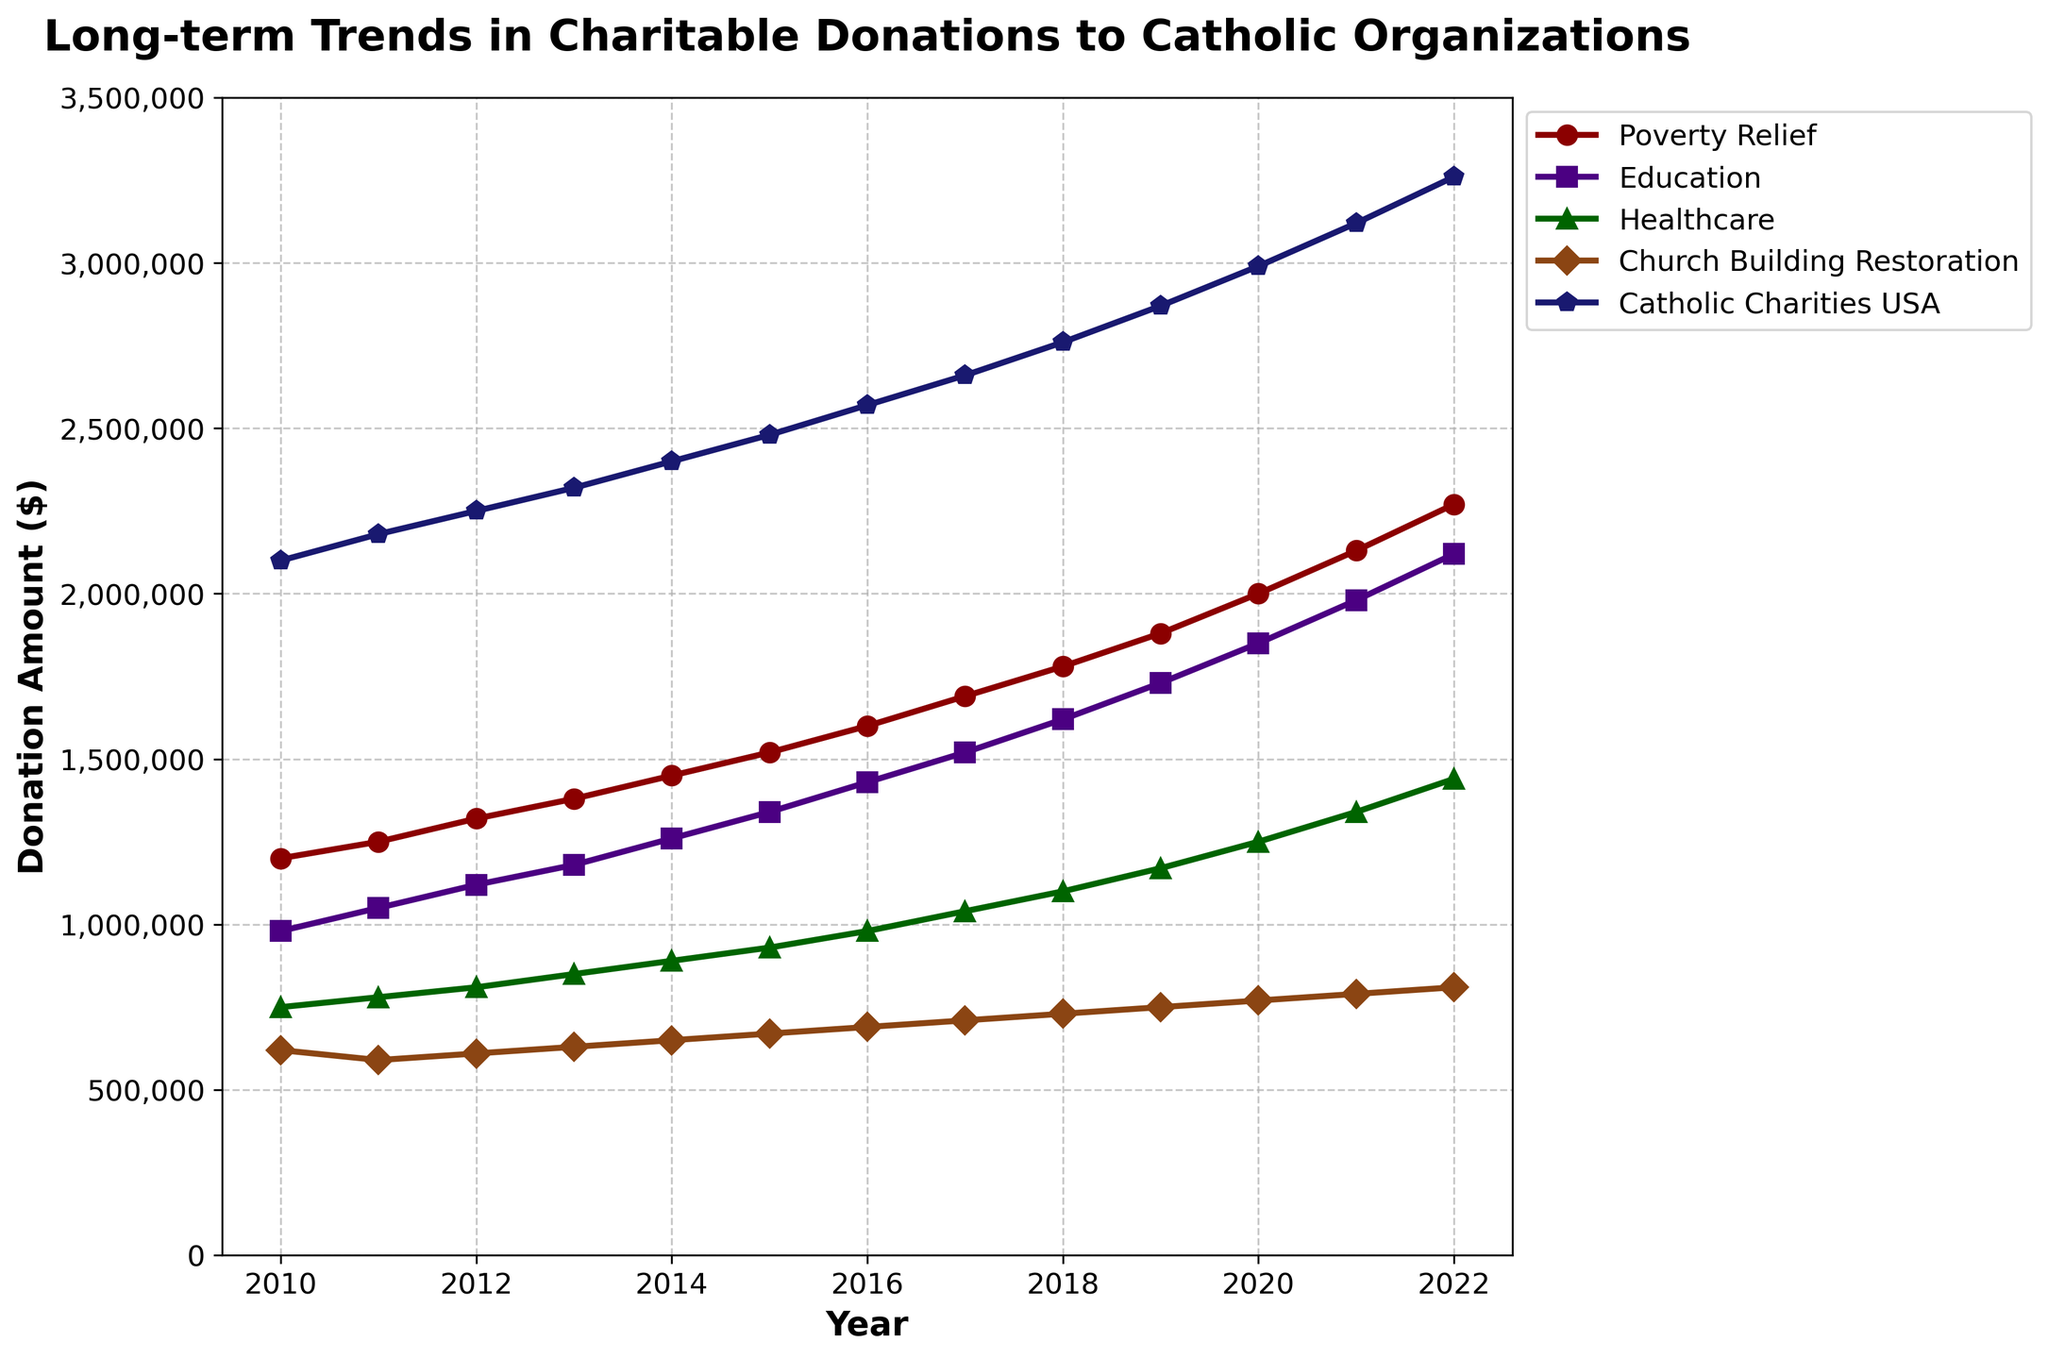What is the total donation amount for Education in 2022? The figure shows the donation amount for Education in 2022 to be $2,120,000. Simply refer to the value marked at 2022 for Education.
Answer: $2,120,000 Which year had the highest donation amount for Poverty Relief? By observing the trend for Poverty Relief, the donation amount has been increasing over the years. The peak value occurs in 2022.
Answer: 2022 In which year did Healthcare donations first surpass $900,000? Track the line for Healthcare and identify the year when it crossed the $900,000 mark. The first year it surpassed this amount is 2015.
Answer: 2015 By how much did the donations to Catholic Charities USA increase from 2010 to 2022? The donation amount in 2010 is $2,100,000 and in 2022 is $3,260,000. The difference is $3,260,000 - $2,100,000 = $1,160,000.
Answer: $1,160,000 Compare the donation amounts between Education and Church Building Restoration in 2017. Which one was higher? In 2017, the donation amount for Education is observed to be higher than that for Church Building Restoration. Education is at $1,520,000 whereas Church Building Restoration is at $710,000.
Answer: Education What is the approximate average annual increase in donations for Poverty Relief from 2010 to 2022? Determine the total increase in donations from 2010 ($1,200,000) to 2022 ($2,270,000), which is $2,270,000 - $1,200,000 = $1,070,000. There are 12 years in this period, so the average annual increase is $1,070,000 / 12 ≈ $89,167.
Answer: $89,167 Which cause had the lowest donation amount in 2020? Observe the donation values for each cause in 2020. Church Building Restoration has the lowest amount at $770,000.
Answer: Church Building Restoration For how many years did the annual donations to Healthcare stay below $1,000,000? Identify the years where Healthcare donations are below $1,000,000. These years are from 2010 to 2016, totaling 7 years.
Answer: 7 years What is the cumulative donation amount for Church Building Restoration from 2010 to 2022? Sum the annual donation amounts for Church Building Restoration from 2010 to 2022: 620,000 + 590,000 + 610,000 + 630,000 + 650,000 + 670,000 + 690,000 + 710,000 + 730,000 + 750,000 + 770,000 + 790,000 + 810,000 = $9,020,000.
Answer: $9,020,000 